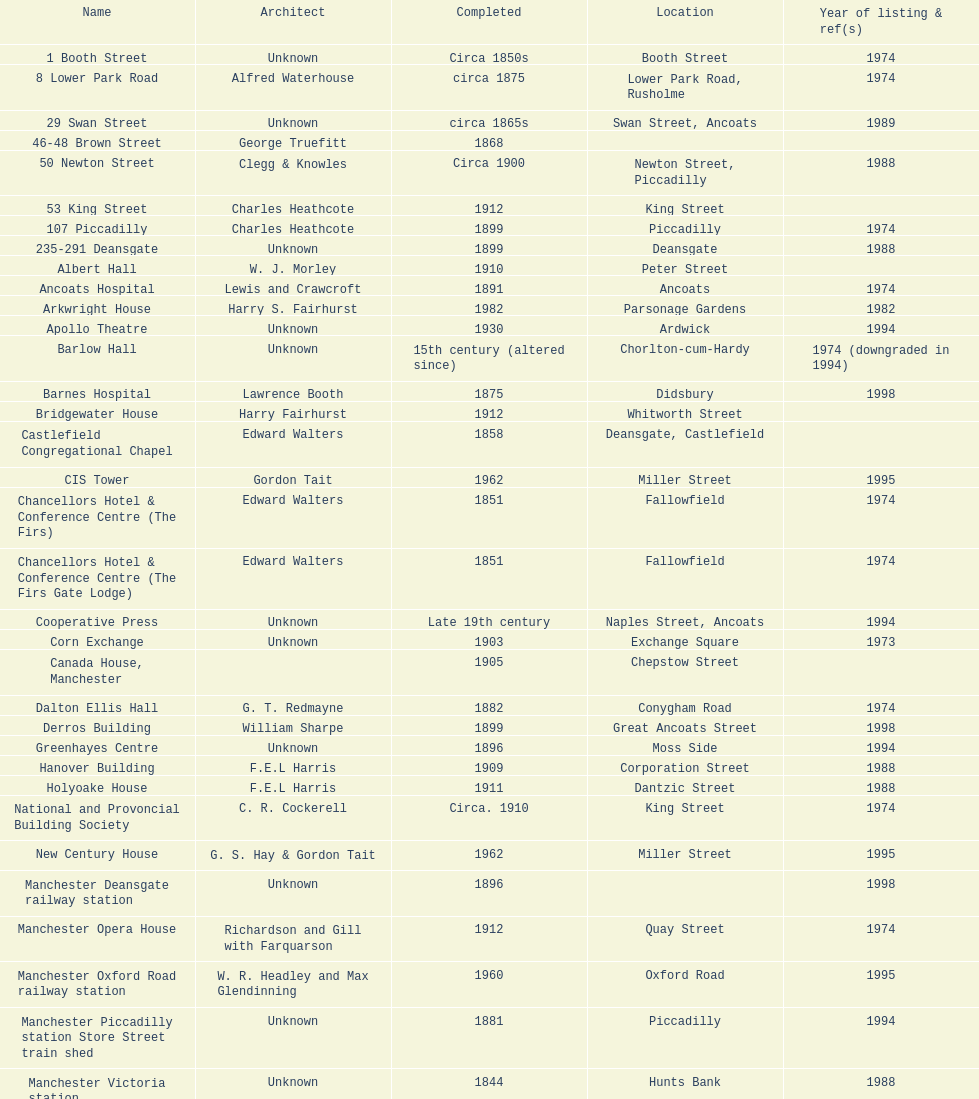How many names are listed with an image? 39. 